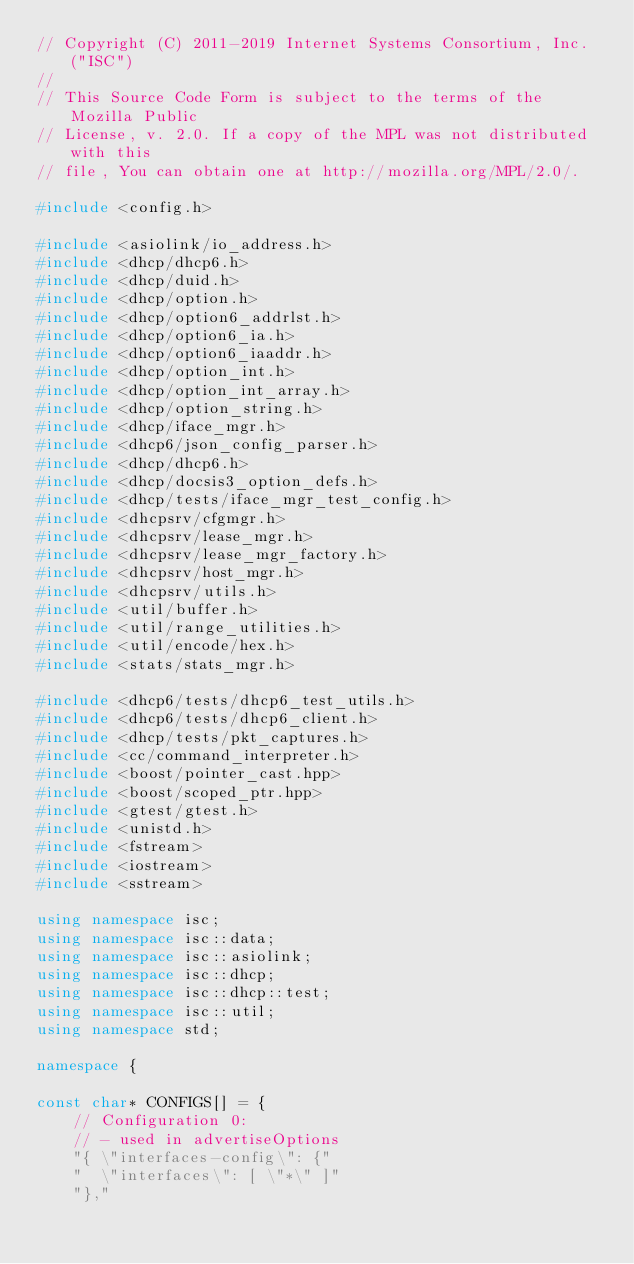Convert code to text. <code><loc_0><loc_0><loc_500><loc_500><_C++_>// Copyright (C) 2011-2019 Internet Systems Consortium, Inc. ("ISC")
//
// This Source Code Form is subject to the terms of the Mozilla Public
// License, v. 2.0. If a copy of the MPL was not distributed with this
// file, You can obtain one at http://mozilla.org/MPL/2.0/.

#include <config.h>

#include <asiolink/io_address.h>
#include <dhcp/dhcp6.h>
#include <dhcp/duid.h>
#include <dhcp/option.h>
#include <dhcp/option6_addrlst.h>
#include <dhcp/option6_ia.h>
#include <dhcp/option6_iaaddr.h>
#include <dhcp/option_int.h>
#include <dhcp/option_int_array.h>
#include <dhcp/option_string.h>
#include <dhcp/iface_mgr.h>
#include <dhcp6/json_config_parser.h>
#include <dhcp/dhcp6.h>
#include <dhcp/docsis3_option_defs.h>
#include <dhcp/tests/iface_mgr_test_config.h>
#include <dhcpsrv/cfgmgr.h>
#include <dhcpsrv/lease_mgr.h>
#include <dhcpsrv/lease_mgr_factory.h>
#include <dhcpsrv/host_mgr.h>
#include <dhcpsrv/utils.h>
#include <util/buffer.h>
#include <util/range_utilities.h>
#include <util/encode/hex.h>
#include <stats/stats_mgr.h>

#include <dhcp6/tests/dhcp6_test_utils.h>
#include <dhcp6/tests/dhcp6_client.h>
#include <dhcp/tests/pkt_captures.h>
#include <cc/command_interpreter.h>
#include <boost/pointer_cast.hpp>
#include <boost/scoped_ptr.hpp>
#include <gtest/gtest.h>
#include <unistd.h>
#include <fstream>
#include <iostream>
#include <sstream>

using namespace isc;
using namespace isc::data;
using namespace isc::asiolink;
using namespace isc::dhcp;
using namespace isc::dhcp::test;
using namespace isc::util;
using namespace std;

namespace {

const char* CONFIGS[] = {
    // Configuration 0:
    // - used in advertiseOptions
    "{ \"interfaces-config\": {"
    "  \"interfaces\": [ \"*\" ]"
    "},"</code> 